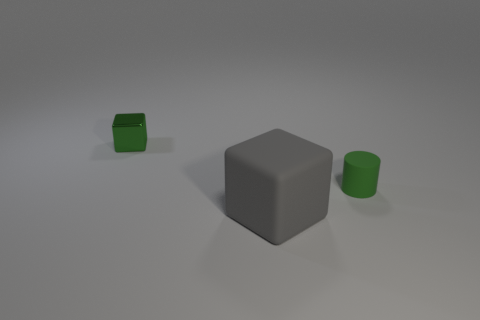Can you describe the positioning of the objects relative to each other? Certainly! In the image, there is a gray matte cube centrally located. To the left and slightly behind it, there's a smaller green matte cube. Directly to the right of the gray cube, at a similar distance, stands a green cylinder. The objects are spaced apart, creating a simple yet intriguing arrangement on a neutral background. 